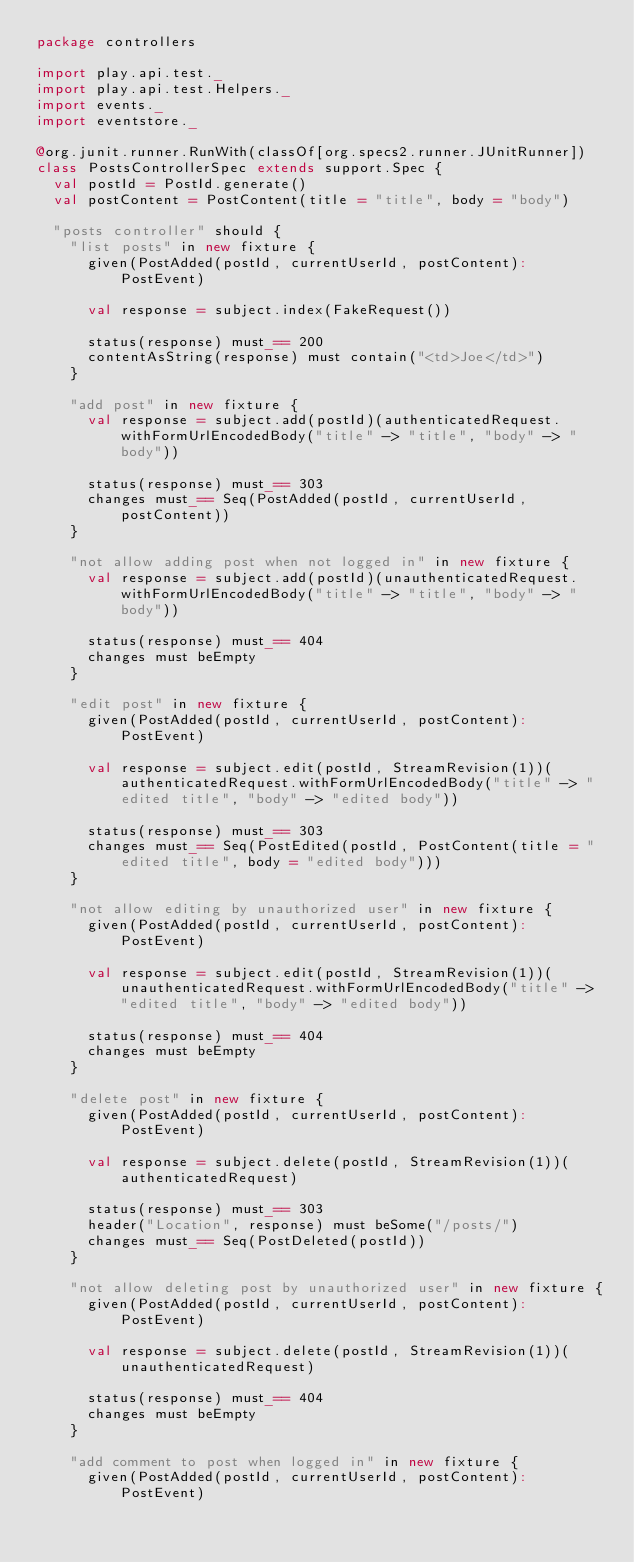Convert code to text. <code><loc_0><loc_0><loc_500><loc_500><_Scala_>package controllers

import play.api.test._
import play.api.test.Helpers._
import events._
import eventstore._

@org.junit.runner.RunWith(classOf[org.specs2.runner.JUnitRunner])
class PostsControllerSpec extends support.Spec {
  val postId = PostId.generate()
  val postContent = PostContent(title = "title", body = "body")

  "posts controller" should {
    "list posts" in new fixture {
      given(PostAdded(postId, currentUserId, postContent): PostEvent)

      val response = subject.index(FakeRequest())

      status(response) must_== 200
      contentAsString(response) must contain("<td>Joe</td>")
    }

    "add post" in new fixture {
      val response = subject.add(postId)(authenticatedRequest.withFormUrlEncodedBody("title" -> "title", "body" -> "body"))

      status(response) must_== 303
      changes must_== Seq(PostAdded(postId, currentUserId, postContent))
    }

    "not allow adding post when not logged in" in new fixture {
      val response = subject.add(postId)(unauthenticatedRequest.withFormUrlEncodedBody("title" -> "title", "body" -> "body"))

      status(response) must_== 404
      changes must beEmpty
    }

    "edit post" in new fixture {
      given(PostAdded(postId, currentUserId, postContent): PostEvent)

      val response = subject.edit(postId, StreamRevision(1))(authenticatedRequest.withFormUrlEncodedBody("title" -> "edited title", "body" -> "edited body"))

      status(response) must_== 303
      changes must_== Seq(PostEdited(postId, PostContent(title = "edited title", body = "edited body")))
    }

    "not allow editing by unauthorized user" in new fixture {
      given(PostAdded(postId, currentUserId, postContent): PostEvent)

      val response = subject.edit(postId, StreamRevision(1))(unauthenticatedRequest.withFormUrlEncodedBody("title" -> "edited title", "body" -> "edited body"))

      status(response) must_== 404
      changes must beEmpty
    }

    "delete post" in new fixture {
      given(PostAdded(postId, currentUserId, postContent): PostEvent)

      val response = subject.delete(postId, StreamRevision(1))(authenticatedRequest)

      status(response) must_== 303
      header("Location", response) must beSome("/posts/")
      changes must_== Seq(PostDeleted(postId))
    }

    "not allow deleting post by unauthorized user" in new fixture {
      given(PostAdded(postId, currentUserId, postContent): PostEvent)

      val response = subject.delete(postId, StreamRevision(1))(unauthenticatedRequest)

      status(response) must_== 404
      changes must beEmpty
    }

    "add comment to post when logged in" in new fixture {
      given(PostAdded(postId, currentUserId, postContent): PostEvent)
</code> 